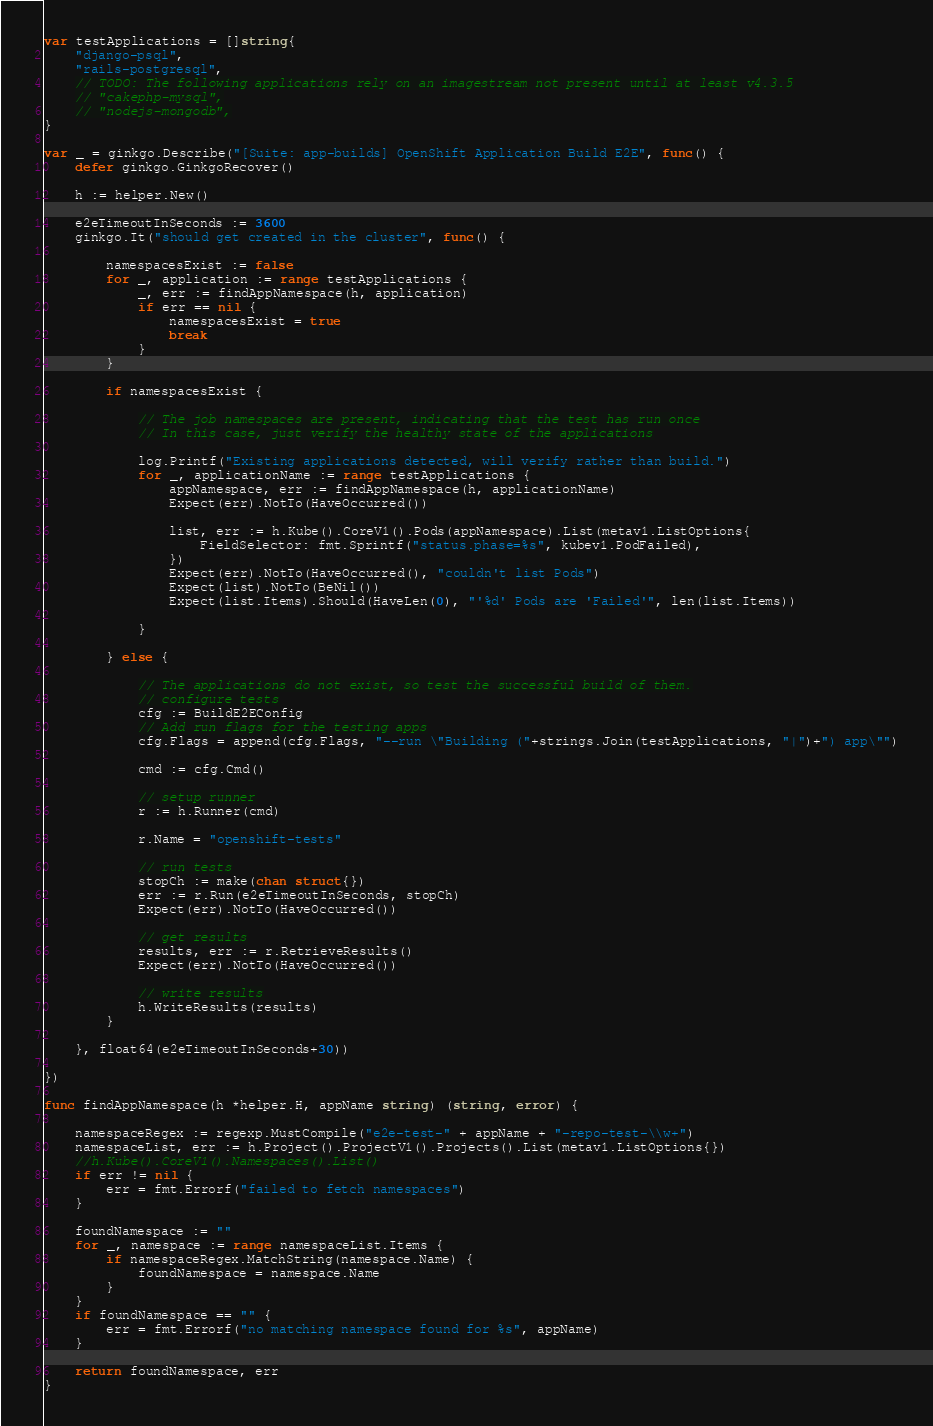<code> <loc_0><loc_0><loc_500><loc_500><_Go_>var testApplications = []string{
	"django-psql",
	"rails-postgresql",
	// TODO: The following applications rely on an imagestream not present until at least v4.3.5
	// "cakephp-mysql",
	// "nodejs-mongodb",
}

var _ = ginkgo.Describe("[Suite: app-builds] OpenShift Application Build E2E", func() {
	defer ginkgo.GinkgoRecover()

	h := helper.New()

	e2eTimeoutInSeconds := 3600
	ginkgo.It("should get created in the cluster", func() {

		namespacesExist := false
		for _, application := range testApplications {
			_, err := findAppNamespace(h, application)
			if err == nil {
				namespacesExist = true
				break
			}
		}

		if namespacesExist {

			// The job namespaces are present, indicating that the test has run once
			// In this case, just verify the healthy state of the applications

			log.Printf("Existing applications detected, will verify rather than build.")
			for _, applicationName := range testApplications {
				appNamespace, err := findAppNamespace(h, applicationName)
				Expect(err).NotTo(HaveOccurred())

				list, err := h.Kube().CoreV1().Pods(appNamespace).List(metav1.ListOptions{
					FieldSelector: fmt.Sprintf("status.phase=%s", kubev1.PodFailed),
				})
				Expect(err).NotTo(HaveOccurred(), "couldn't list Pods")
				Expect(list).NotTo(BeNil())
				Expect(list.Items).Should(HaveLen(0), "'%d' Pods are 'Failed'", len(list.Items))

			}

		} else {

			// The applications do not exist, so test the successful build of them.
			// configure tests
			cfg := BuildE2EConfig
			// Add run flags for the testing apps
			cfg.Flags = append(cfg.Flags, "--run \"Building ("+strings.Join(testApplications, "|")+") app\"")

			cmd := cfg.Cmd()

			// setup runner
			r := h.Runner(cmd)

			r.Name = "openshift-tests"

			// run tests
			stopCh := make(chan struct{})
			err := r.Run(e2eTimeoutInSeconds, stopCh)
			Expect(err).NotTo(HaveOccurred())

			// get results
			results, err := r.RetrieveResults()
			Expect(err).NotTo(HaveOccurred())

			// write results
			h.WriteResults(results)
		}

	}, float64(e2eTimeoutInSeconds+30))

})

func findAppNamespace(h *helper.H, appName string) (string, error) {

	namespaceRegex := regexp.MustCompile("e2e-test-" + appName + "-repo-test-\\w+")
	namespaceList, err := h.Project().ProjectV1().Projects().List(metav1.ListOptions{})
	//h.Kube().CoreV1().Namespaces().List()
	if err != nil {
		err = fmt.Errorf("failed to fetch namespaces")
	}

	foundNamespace := ""
	for _, namespace := range namespaceList.Items {
		if namespaceRegex.MatchString(namespace.Name) {
			foundNamespace = namespace.Name
		}
	}
	if foundNamespace == "" {
		err = fmt.Errorf("no matching namespace found for %s", appName)
	}

	return foundNamespace, err
}
</code> 